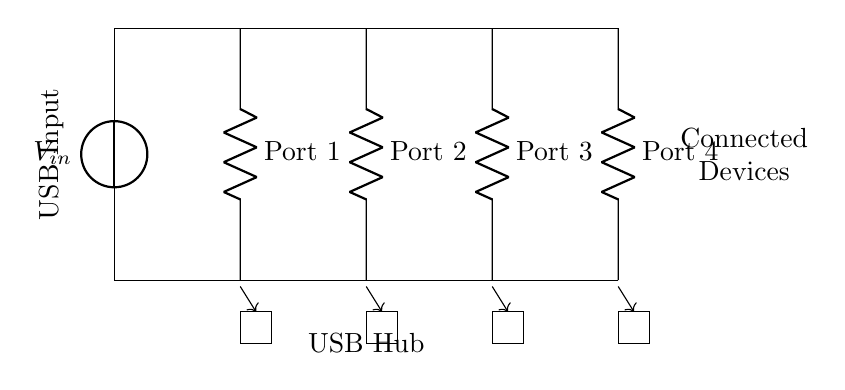What is the input voltage of the USB hub? The input voltage is indicated as V in the diagram, which typically corresponds to the standard USB voltage of 5 volts.
Answer: 5 volts How many USB ports are shown in this circuit? The circuit diagram displays four individual USB ports, each represented as a resistor leading from the main line to the ground.
Answer: Four What does the horizontal line represent in this circuit? The horizontal line signifies the common power line that distributes the input voltage (5 volts) to each of the USB ports, indicating a parallel connection.
Answer: Common power line Which component connects to the output devices? The rectangles below each port represent the connected devices, which receive power through the ports.
Answer: Connected devices Describe the configuration type of the circuit. This circuit is configured in parallel since each port is connected directly to the main power line, allowing simultaneous usage without affecting each other's voltage or current by sharing the same input source.
Answer: Parallel What happens if one port fails? In a parallel configuration, if one port fails, the remaining ports will continue to function normally since each port is independently connected to the power source, meaning they do not rely on each other to operate.
Answer: Remaining ports function 